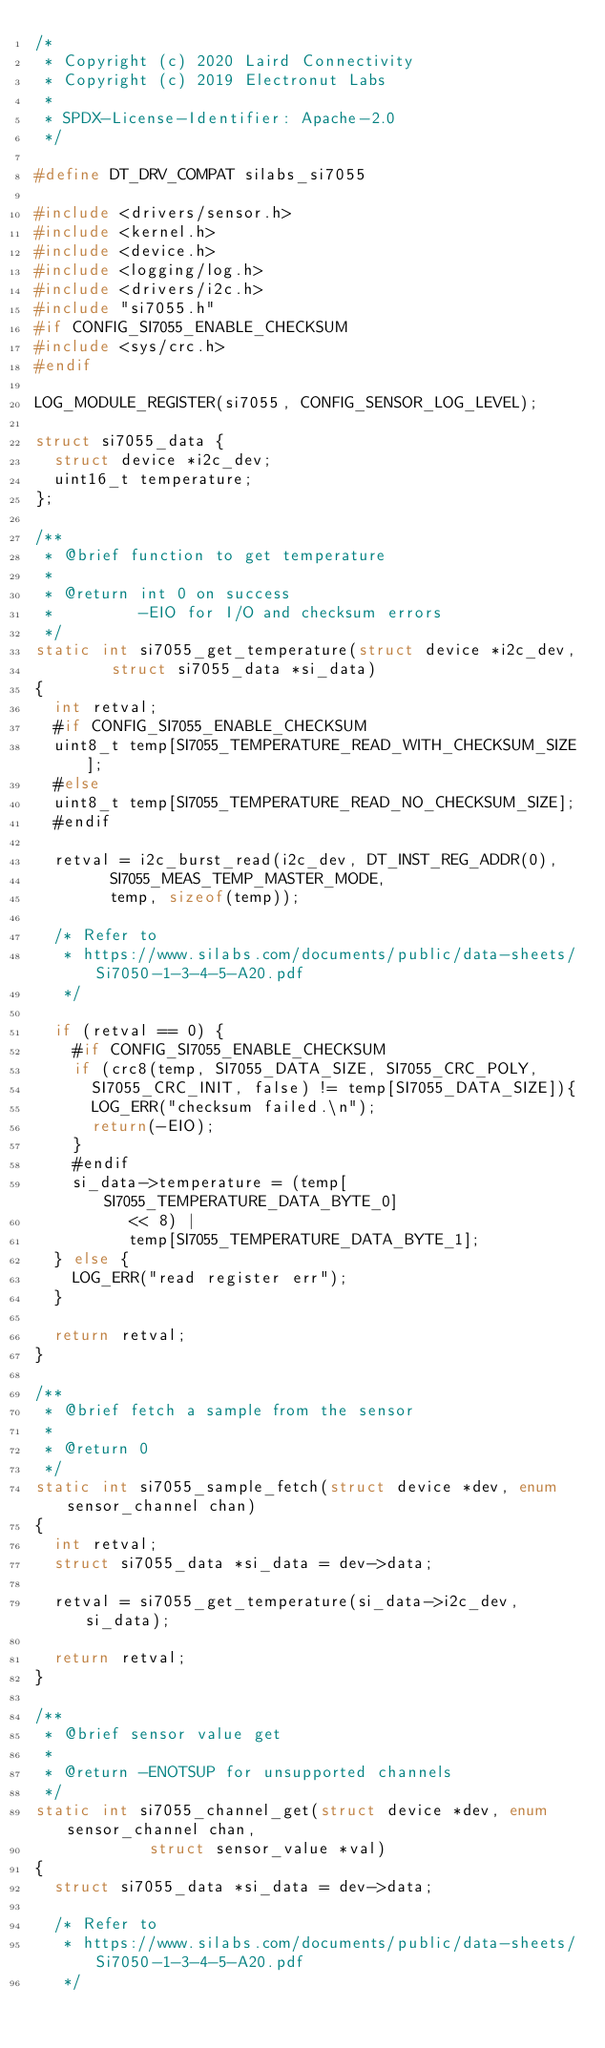<code> <loc_0><loc_0><loc_500><loc_500><_C_>/*
 * Copyright (c) 2020 Laird Connectivity
 * Copyright (c) 2019 Electronut Labs
 *
 * SPDX-License-Identifier: Apache-2.0
 */

#define DT_DRV_COMPAT silabs_si7055

#include <drivers/sensor.h>
#include <kernel.h>
#include <device.h>
#include <logging/log.h>
#include <drivers/i2c.h>
#include "si7055.h"
#if CONFIG_SI7055_ENABLE_CHECKSUM
#include <sys/crc.h>
#endif

LOG_MODULE_REGISTER(si7055, CONFIG_SENSOR_LOG_LEVEL);

struct si7055_data {
	struct device *i2c_dev;
	uint16_t temperature;
};

/**
 * @brief function to get temperature
 *
 * @return int 0 on success
 *         -EIO for I/O and checksum errors
 */
static int si7055_get_temperature(struct device *i2c_dev,
				struct si7055_data *si_data)
{
	int retval;
	#if CONFIG_SI7055_ENABLE_CHECKSUM
	uint8_t temp[SI7055_TEMPERATURE_READ_WITH_CHECKSUM_SIZE];
	#else
	uint8_t temp[SI7055_TEMPERATURE_READ_NO_CHECKSUM_SIZE];
	#endif

	retval = i2c_burst_read(i2c_dev, DT_INST_REG_ADDR(0),
				SI7055_MEAS_TEMP_MASTER_MODE,
				temp, sizeof(temp));

	/* Refer to
	 * https://www.silabs.com/documents/public/data-sheets/Si7050-1-3-4-5-A20.pdf
	 */

	if (retval == 0) {
		#if CONFIG_SI7055_ENABLE_CHECKSUM
		if (crc8(temp, SI7055_DATA_SIZE, SI7055_CRC_POLY,
			SI7055_CRC_INIT, false) != temp[SI7055_DATA_SIZE]){
			LOG_ERR("checksum failed.\n");
			return(-EIO);
		}
		#endif
		si_data->temperature = (temp[SI7055_TEMPERATURE_DATA_BYTE_0]
					<< 8) |
					temp[SI7055_TEMPERATURE_DATA_BYTE_1];
	} else {
		LOG_ERR("read register err");
	}

	return retval;
}

/**
 * @brief fetch a sample from the sensor
 *
 * @return 0
 */
static int si7055_sample_fetch(struct device *dev, enum sensor_channel chan)
{
	int retval;
	struct si7055_data *si_data = dev->data;

	retval = si7055_get_temperature(si_data->i2c_dev, si_data);

	return retval;
}

/**
 * @brief sensor value get
 *
 * @return -ENOTSUP for unsupported channels
 */
static int si7055_channel_get(struct device *dev, enum sensor_channel chan,
			      struct sensor_value *val)
{
	struct si7055_data *si_data = dev->data;

	/* Refer to
	 * https://www.silabs.com/documents/public/data-sheets/Si7050-1-3-4-5-A20.pdf
	 */
</code> 